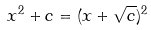Convert formula to latex. <formula><loc_0><loc_0><loc_500><loc_500>x ^ { 2 } + c = ( x + \sqrt { c } ) ^ { 2 }</formula> 